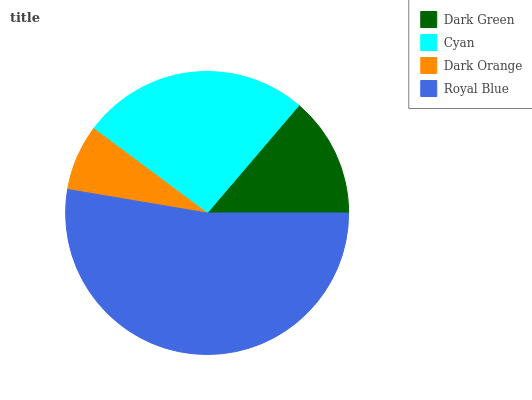Is Dark Orange the minimum?
Answer yes or no. Yes. Is Royal Blue the maximum?
Answer yes or no. Yes. Is Cyan the minimum?
Answer yes or no. No. Is Cyan the maximum?
Answer yes or no. No. Is Cyan greater than Dark Green?
Answer yes or no. Yes. Is Dark Green less than Cyan?
Answer yes or no. Yes. Is Dark Green greater than Cyan?
Answer yes or no. No. Is Cyan less than Dark Green?
Answer yes or no. No. Is Cyan the high median?
Answer yes or no. Yes. Is Dark Green the low median?
Answer yes or no. Yes. Is Royal Blue the high median?
Answer yes or no. No. Is Cyan the low median?
Answer yes or no. No. 